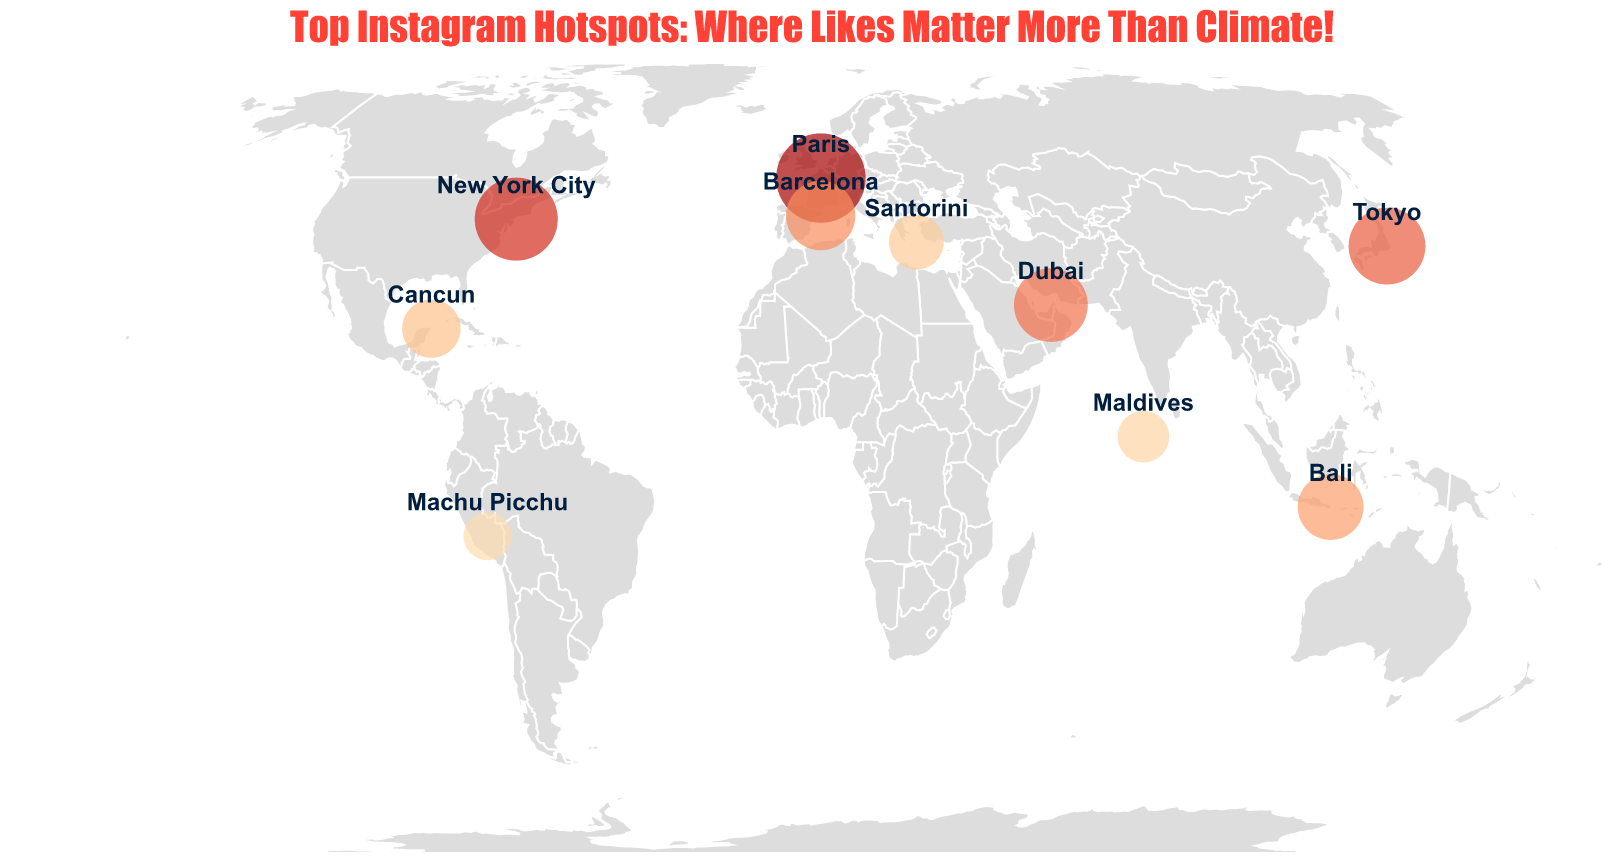What is the most popular tourist destination according to Instagram hashtags? The destination with the highest Instagram hashtag count is shown as Paris with 131,000,000 hashtags.
Answer: Paris Which location has the least number of Instagram hashtags? Among the plotted locations, Machu Picchu has the lowest number of Instagram hashtags, at 33,000,000.
Answer: Machu Picchu How does New York City's hashtag popularity compare to Dubai's? New York City has 112,000,000 hashtags, which is more than Dubai's 87,000,000.
Answer: New York City has more hashtags than Dubai Sum the hashtag counts for Bali and the Maldives. Bali has 68,000,000 hashtags, and the Maldives has 39,000,000. The sum is 68,000,000 + 39,000,000 = 107,000,000.
Answer: 107,000,000 What is the median value of hashtag counts for all listed destinations? The hashtag counts in ascending order are: Machu Picchu (33,000,000), Maldives (39,000,000), Santorini (45,000,000), Cancun (52,000,000), Bali (68,000,000), Barcelona (76,000,000), Dubai (87,000,000), Tokyo (95,000,000), New York City (112,000,000), Paris (131,000,000). With 10 values, the median is the average of the 5th and 6th values: (68,000,000 + 76,000,000) / 2 = 72,000,000.
Answer: 72,000,000 Which location has the second-highest number of Instagram hashtags? New York City, with 112,000,000 hashtags, follows Paris in popularity.
Answer: New York City How much more popular, in terms of Instagram hashtags, is Paris compared to Santorini? Paris has 131,000,000 hashtags, Santorini has 45,000,000. The difference is 131,000,000 - 45,000,000 = 86,000,000.
Answer: 86,000,000 What is the color scheme used in the plot for representing the hashtag count? The color scheme used in the plot for representing Instagram hashtag counts is a range of orangered.
Answer: orangered Identify the destination with the hashtag comment "Plastic straws for days! #BeachLife". The comment "Plastic straws for days! #BeachLife" is associated with Cancun.
Answer: Cancun Name all the destinations identified on the plot from the continent of Europe. The destinations in Europe are Paris, Santorini, and Barcelona.
Answer: Paris, Santorini, Barcelona 